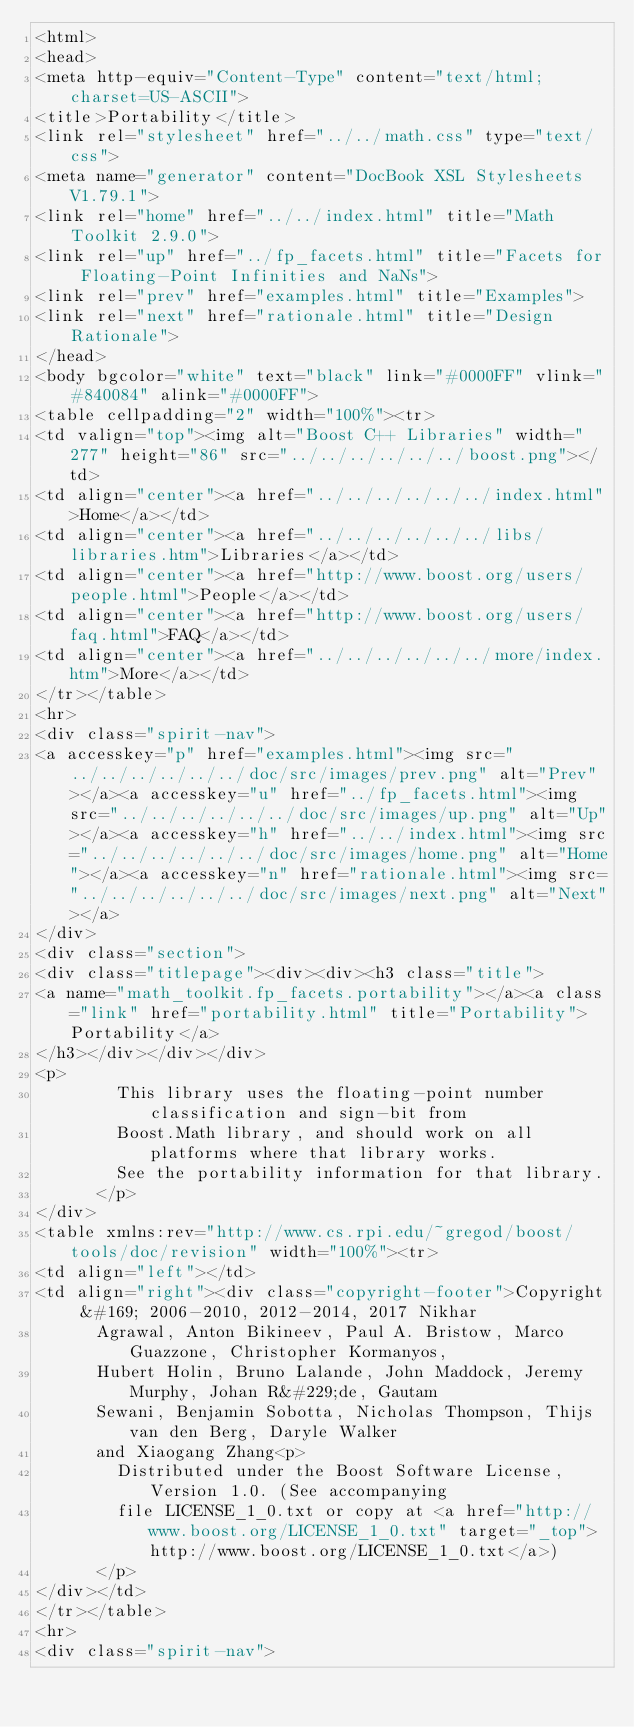Convert code to text. <code><loc_0><loc_0><loc_500><loc_500><_HTML_><html>
<head>
<meta http-equiv="Content-Type" content="text/html; charset=US-ASCII">
<title>Portability</title>
<link rel="stylesheet" href="../../math.css" type="text/css">
<meta name="generator" content="DocBook XSL Stylesheets V1.79.1">
<link rel="home" href="../../index.html" title="Math Toolkit 2.9.0">
<link rel="up" href="../fp_facets.html" title="Facets for Floating-Point Infinities and NaNs">
<link rel="prev" href="examples.html" title="Examples">
<link rel="next" href="rationale.html" title="Design Rationale">
</head>
<body bgcolor="white" text="black" link="#0000FF" vlink="#840084" alink="#0000FF">
<table cellpadding="2" width="100%"><tr>
<td valign="top"><img alt="Boost C++ Libraries" width="277" height="86" src="../../../../../../boost.png"></td>
<td align="center"><a href="../../../../../../index.html">Home</a></td>
<td align="center"><a href="../../../../../../libs/libraries.htm">Libraries</a></td>
<td align="center"><a href="http://www.boost.org/users/people.html">People</a></td>
<td align="center"><a href="http://www.boost.org/users/faq.html">FAQ</a></td>
<td align="center"><a href="../../../../../../more/index.htm">More</a></td>
</tr></table>
<hr>
<div class="spirit-nav">
<a accesskey="p" href="examples.html"><img src="../../../../../../doc/src/images/prev.png" alt="Prev"></a><a accesskey="u" href="../fp_facets.html"><img src="../../../../../../doc/src/images/up.png" alt="Up"></a><a accesskey="h" href="../../index.html"><img src="../../../../../../doc/src/images/home.png" alt="Home"></a><a accesskey="n" href="rationale.html"><img src="../../../../../../doc/src/images/next.png" alt="Next"></a>
</div>
<div class="section">
<div class="titlepage"><div><div><h3 class="title">
<a name="math_toolkit.fp_facets.portability"></a><a class="link" href="portability.html" title="Portability">Portability</a>
</h3></div></div></div>
<p>
        This library uses the floating-point number classification and sign-bit from
        Boost.Math library, and should work on all platforms where that library works.
        See the portability information for that library.
      </p>
</div>
<table xmlns:rev="http://www.cs.rpi.edu/~gregod/boost/tools/doc/revision" width="100%"><tr>
<td align="left"></td>
<td align="right"><div class="copyright-footer">Copyright &#169; 2006-2010, 2012-2014, 2017 Nikhar
      Agrawal, Anton Bikineev, Paul A. Bristow, Marco Guazzone, Christopher Kormanyos,
      Hubert Holin, Bruno Lalande, John Maddock, Jeremy Murphy, Johan R&#229;de, Gautam
      Sewani, Benjamin Sobotta, Nicholas Thompson, Thijs van den Berg, Daryle Walker
      and Xiaogang Zhang<p>
        Distributed under the Boost Software License, Version 1.0. (See accompanying
        file LICENSE_1_0.txt or copy at <a href="http://www.boost.org/LICENSE_1_0.txt" target="_top">http://www.boost.org/LICENSE_1_0.txt</a>)
      </p>
</div></td>
</tr></table>
<hr>
<div class="spirit-nav"></code> 